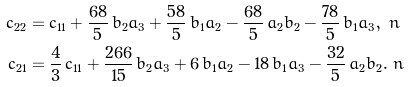Convert formula to latex. <formula><loc_0><loc_0><loc_500><loc_500>c _ { 2 2 } & = c _ { 1 1 } + { \frac { 6 8 } { 5 } } \, b _ { 2 } a _ { 3 } + { \frac { 5 8 } { 5 } } \, b _ { 1 } a _ { 2 } - { \frac { 6 8 } { 5 } } \, a _ { 2 } b _ { 2 } - { \frac { 7 8 } { 5 } } \, b _ { 1 } a _ { 3 } , \ n \\ c _ { 2 1 } & = \frac { 4 } { 3 } \, c _ { 1 1 } + { \frac { 2 6 6 } { 1 5 } } \, b _ { 2 } a _ { 3 } + 6 \, b _ { 1 } a _ { 2 } - 1 8 \, b _ { 1 } a _ { 3 } - { \frac { 3 2 } { 5 } } \, a _ { 2 } b _ { 2 } . \ n</formula> 